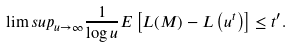<formula> <loc_0><loc_0><loc_500><loc_500>\lim s u p _ { u \to \infty } \frac { 1 } { \log u } { E } \left [ L ( M ) - L \left ( u ^ { t } \right ) \right ] \leq t ^ { \prime } .</formula> 